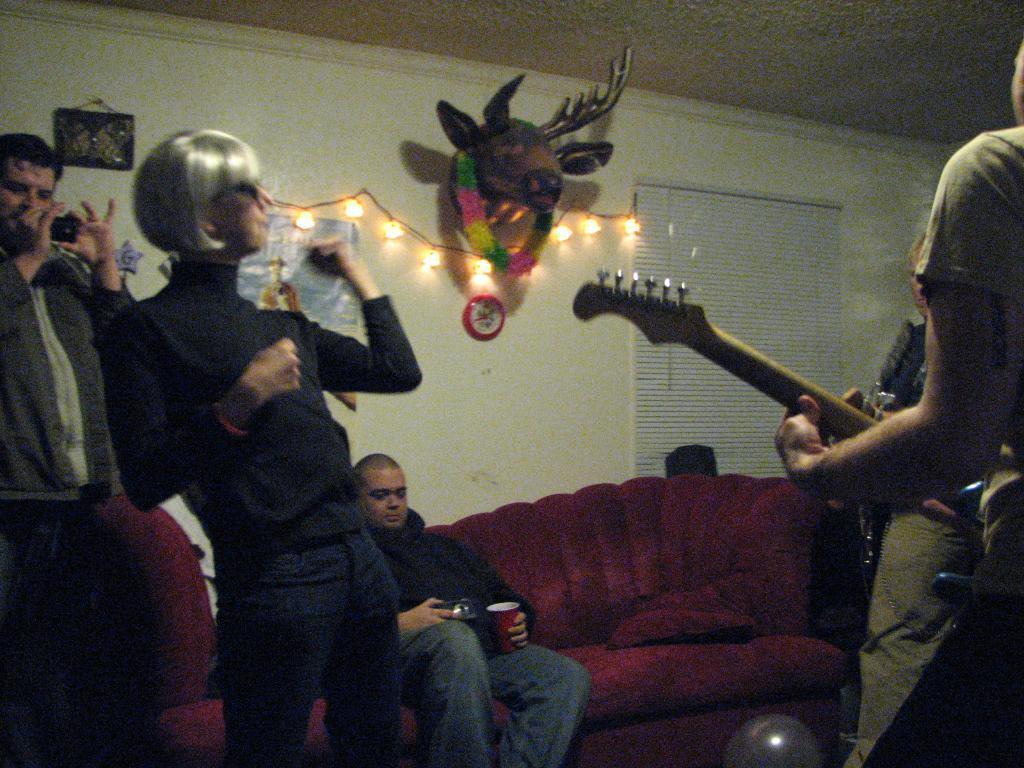In one or two sentences, can you explain what this image depicts? This is a room there are few people partying. On the right a person is playing guitar. On the left a person i s recording in his phone. And a person is sitting on the sofa. On the wall there is a poster,frame and a light hanging on it. 